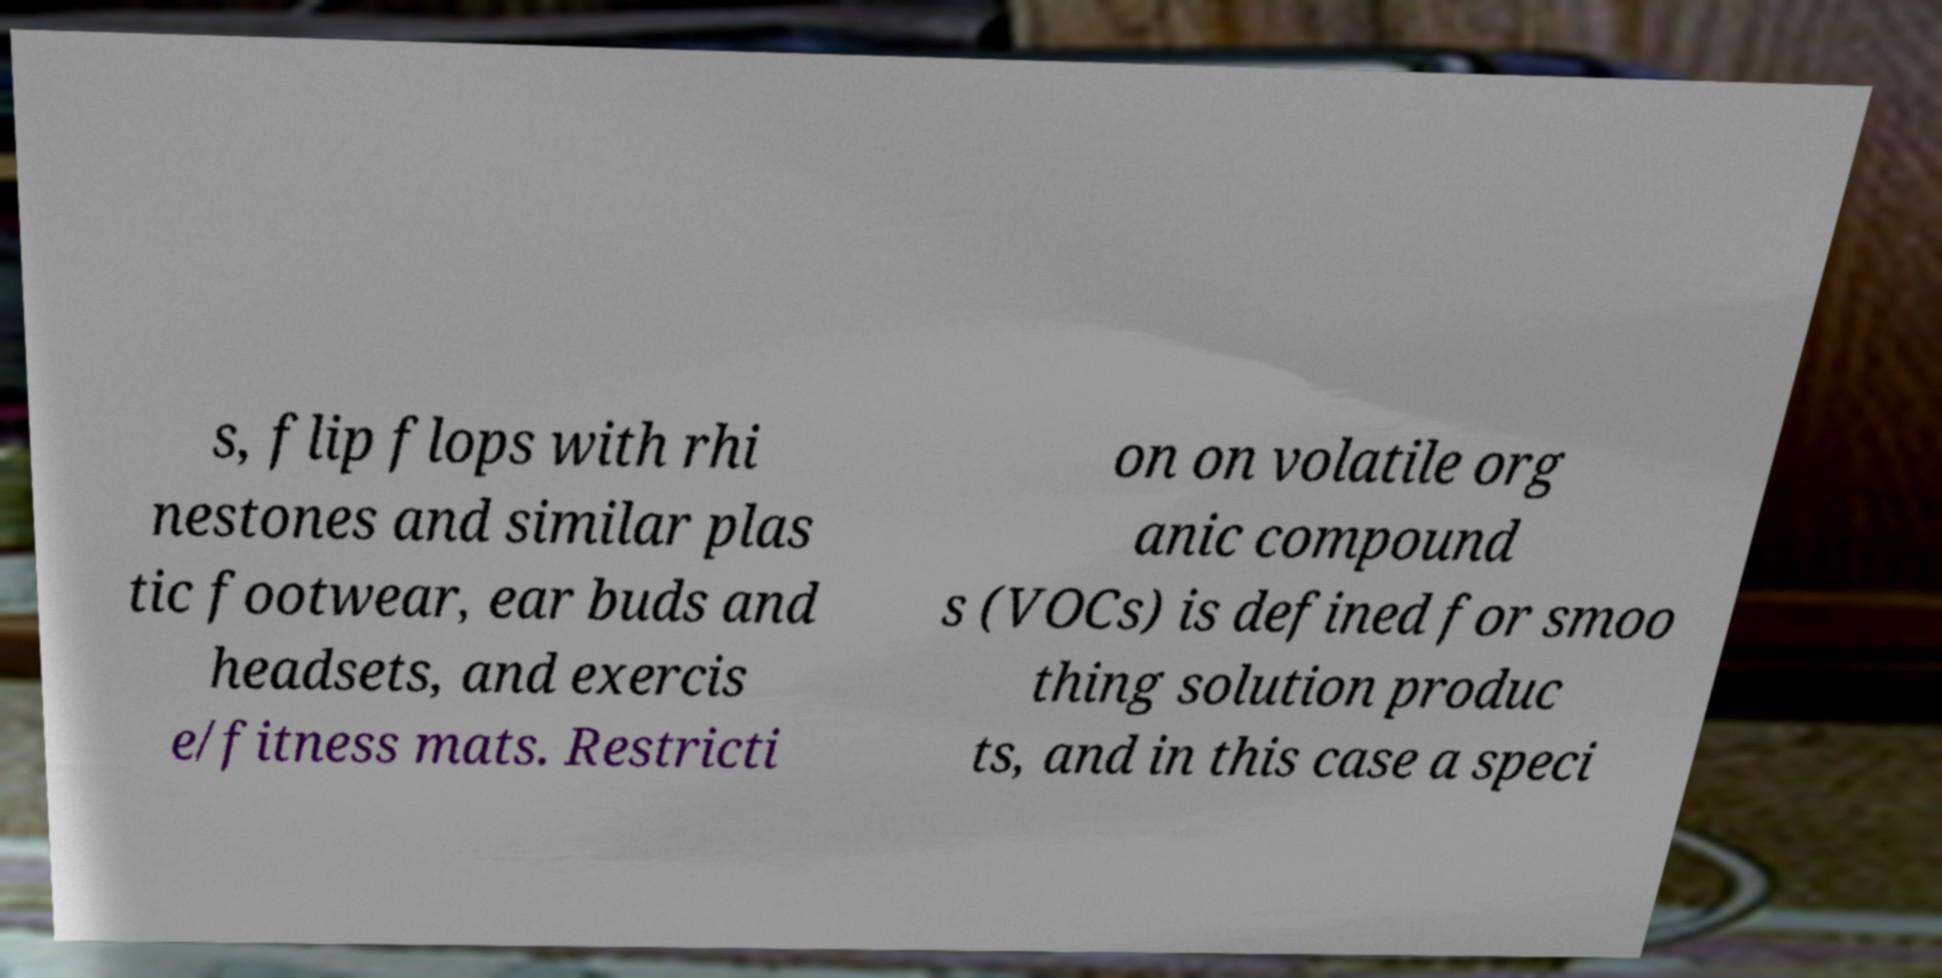What messages or text are displayed in this image? I need them in a readable, typed format. s, flip flops with rhi nestones and similar plas tic footwear, ear buds and headsets, and exercis e/fitness mats. Restricti on on volatile org anic compound s (VOCs) is defined for smoo thing solution produc ts, and in this case a speci 